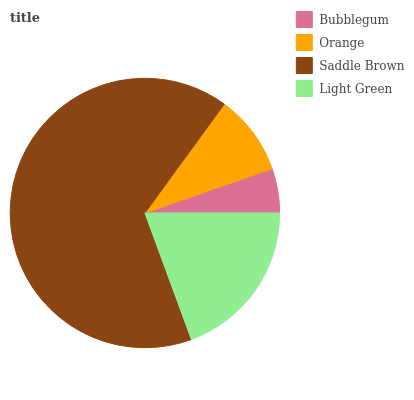Is Bubblegum the minimum?
Answer yes or no. Yes. Is Saddle Brown the maximum?
Answer yes or no. Yes. Is Orange the minimum?
Answer yes or no. No. Is Orange the maximum?
Answer yes or no. No. Is Orange greater than Bubblegum?
Answer yes or no. Yes. Is Bubblegum less than Orange?
Answer yes or no. Yes. Is Bubblegum greater than Orange?
Answer yes or no. No. Is Orange less than Bubblegum?
Answer yes or no. No. Is Light Green the high median?
Answer yes or no. Yes. Is Orange the low median?
Answer yes or no. Yes. Is Orange the high median?
Answer yes or no. No. Is Bubblegum the low median?
Answer yes or no. No. 